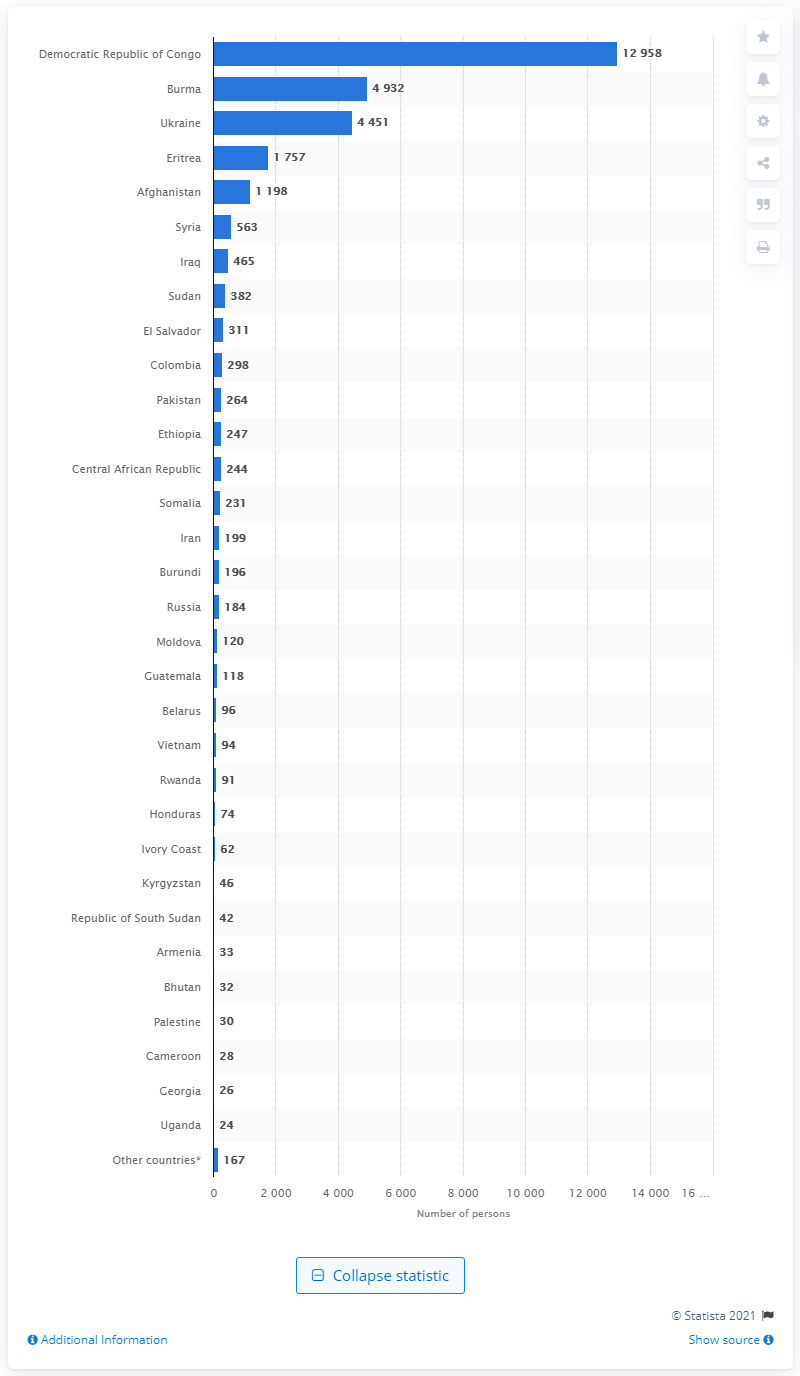Draw attention to some important aspects in this diagram. During the fiscal year of 2019, refugees from Burma arrived in the United States. 